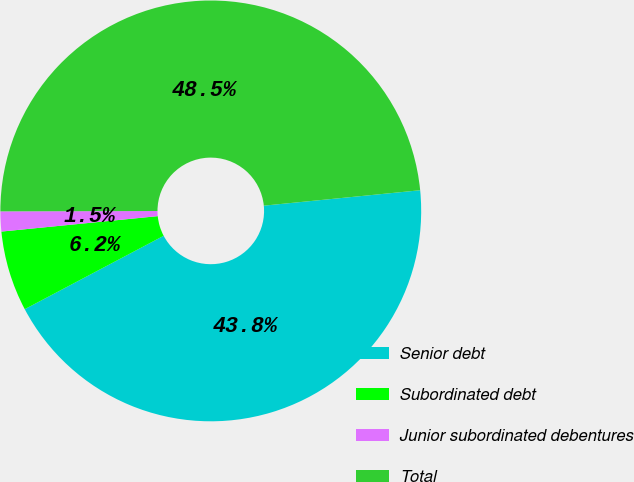Convert chart. <chart><loc_0><loc_0><loc_500><loc_500><pie_chart><fcel>Senior debt<fcel>Subordinated debt<fcel>Junior subordinated debentures<fcel>Total<nl><fcel>43.83%<fcel>6.17%<fcel>1.53%<fcel>48.47%<nl></chart> 